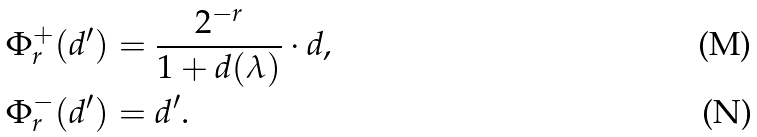<formula> <loc_0><loc_0><loc_500><loc_500>\Phi ^ { + } _ { r } ( d ^ { \prime } ) & = \frac { 2 ^ { - r } } { 1 + d ( \lambda ) } \cdot d , \\ \Phi ^ { - } _ { r } ( d ^ { \prime } ) & = d ^ { \prime } .</formula> 